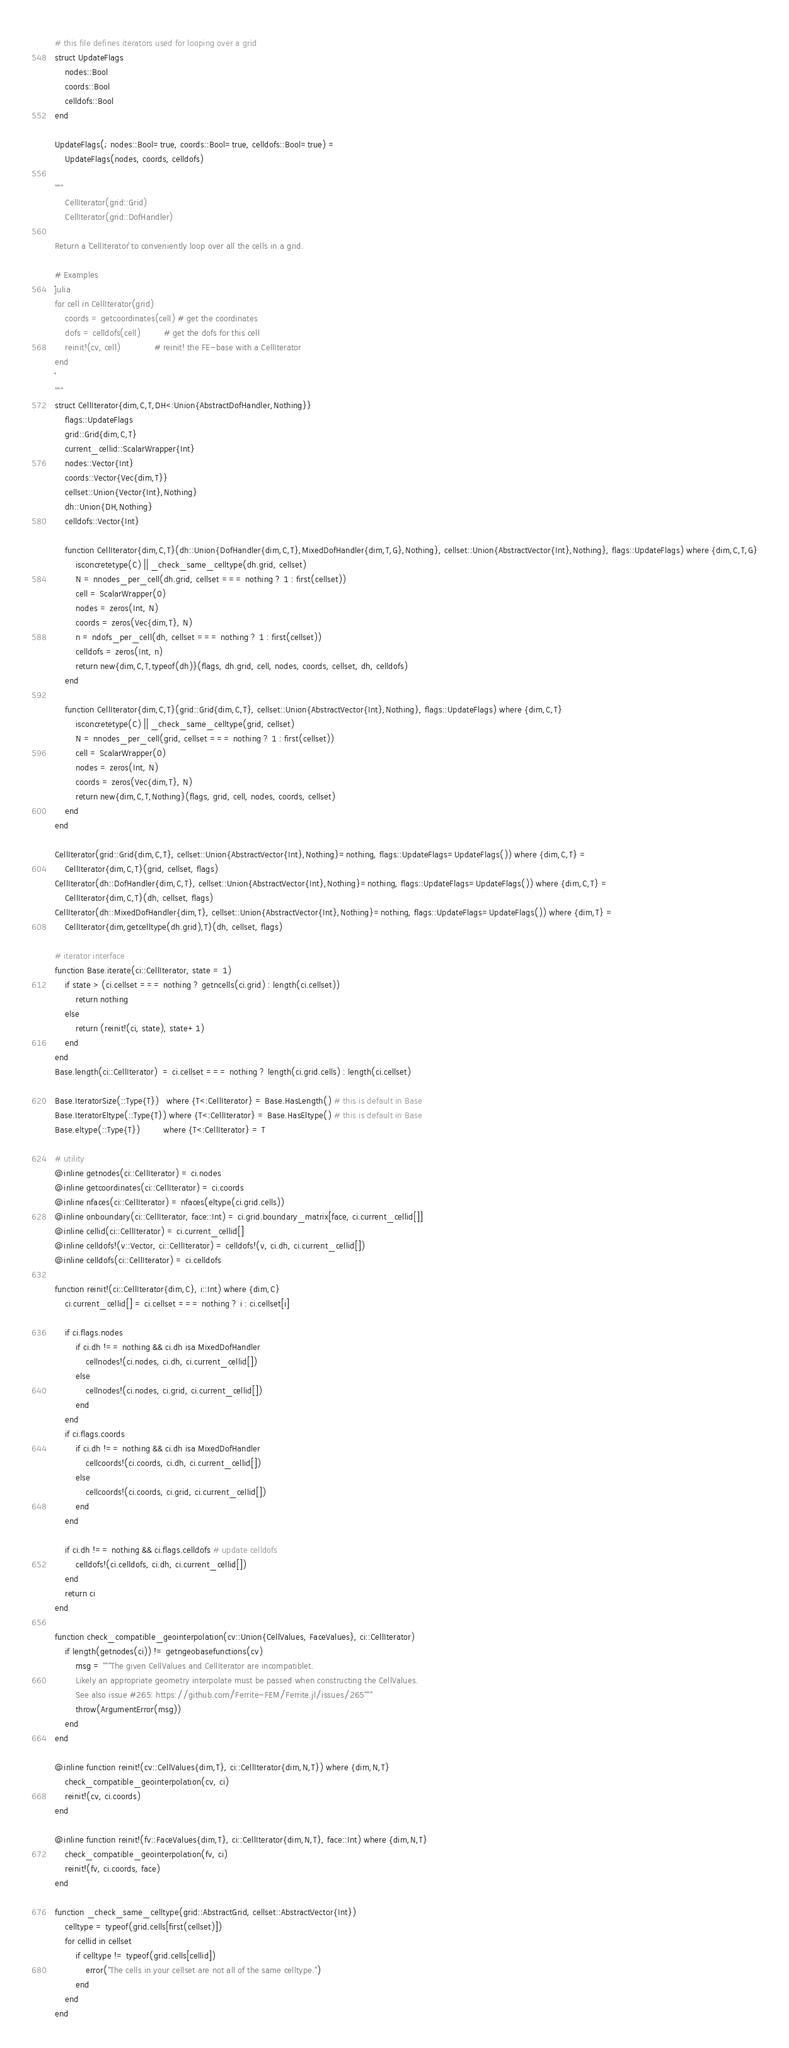<code> <loc_0><loc_0><loc_500><loc_500><_Julia_># this file defines iterators used for looping over a grid
struct UpdateFlags
    nodes::Bool
    coords::Bool
    celldofs::Bool
end

UpdateFlags(; nodes::Bool=true, coords::Bool=true, celldofs::Bool=true) =
    UpdateFlags(nodes, coords, celldofs)

"""
    CellIterator(grid::Grid)
    CellIterator(grid::DofHandler)

Return a `CellIterator` to conveniently loop over all the cells in a grid.

# Examples
```julia
for cell in CellIterator(grid)
    coords = getcoordinates(cell) # get the coordinates
    dofs = celldofs(cell)         # get the dofs for this cell
    reinit!(cv, cell)             # reinit! the FE-base with a CellIterator
end
```
"""
struct CellIterator{dim,C,T,DH<:Union{AbstractDofHandler,Nothing}}
    flags::UpdateFlags
    grid::Grid{dim,C,T}
    current_cellid::ScalarWrapper{Int}
    nodes::Vector{Int}
    coords::Vector{Vec{dim,T}}
    cellset::Union{Vector{Int},Nothing}
    dh::Union{DH,Nothing}
    celldofs::Vector{Int}

    function CellIterator{dim,C,T}(dh::Union{DofHandler{dim,C,T},MixedDofHandler{dim,T,G},Nothing}, cellset::Union{AbstractVector{Int},Nothing}, flags::UpdateFlags) where {dim,C,T,G}
        isconcretetype(C) || _check_same_celltype(dh.grid, cellset)
        N = nnodes_per_cell(dh.grid, cellset === nothing ? 1 : first(cellset))
        cell = ScalarWrapper(0)
        nodes = zeros(Int, N)
        coords = zeros(Vec{dim,T}, N)
        n = ndofs_per_cell(dh, cellset === nothing ? 1 : first(cellset))
        celldofs = zeros(Int, n)
        return new{dim,C,T,typeof(dh)}(flags, dh.grid, cell, nodes, coords, cellset, dh, celldofs)
    end

    function CellIterator{dim,C,T}(grid::Grid{dim,C,T}, cellset::Union{AbstractVector{Int},Nothing}, flags::UpdateFlags) where {dim,C,T}
        isconcretetype(C) || _check_same_celltype(grid, cellset)
        N = nnodes_per_cell(grid, cellset === nothing ? 1 : first(cellset))
        cell = ScalarWrapper(0)
        nodes = zeros(Int, N)
        coords = zeros(Vec{dim,T}, N)
        return new{dim,C,T,Nothing}(flags, grid, cell, nodes, coords, cellset)
    end
end

CellIterator(grid::Grid{dim,C,T}, cellset::Union{AbstractVector{Int},Nothing}=nothing, flags::UpdateFlags=UpdateFlags()) where {dim,C,T} =
    CellIterator{dim,C,T}(grid, cellset, flags)
CellIterator(dh::DofHandler{dim,C,T}, cellset::Union{AbstractVector{Int},Nothing}=nothing, flags::UpdateFlags=UpdateFlags()) where {dim,C,T} =
    CellIterator{dim,C,T}(dh, cellset, flags)
CellIterator(dh::MixedDofHandler{dim,T}, cellset::Union{AbstractVector{Int},Nothing}=nothing, flags::UpdateFlags=UpdateFlags()) where {dim,T} =
    CellIterator{dim,getcelltype(dh.grid),T}(dh, cellset, flags)

# iterator interface
function Base.iterate(ci::CellIterator, state = 1)
    if state > (ci.cellset === nothing ? getncells(ci.grid) : length(ci.cellset))
        return nothing
    else
        return (reinit!(ci, state), state+1)
    end
end
Base.length(ci::CellIterator)  = ci.cellset === nothing ? length(ci.grid.cells) : length(ci.cellset)

Base.IteratorSize(::Type{T})   where {T<:CellIterator} = Base.HasLength() # this is default in Base
Base.IteratorEltype(::Type{T}) where {T<:CellIterator} = Base.HasEltype() # this is default in Base
Base.eltype(::Type{T})         where {T<:CellIterator} = T

# utility
@inline getnodes(ci::CellIterator) = ci.nodes
@inline getcoordinates(ci::CellIterator) = ci.coords
@inline nfaces(ci::CellIterator) = nfaces(eltype(ci.grid.cells))
@inline onboundary(ci::CellIterator, face::Int) = ci.grid.boundary_matrix[face, ci.current_cellid[]]
@inline cellid(ci::CellIterator) = ci.current_cellid[]
@inline celldofs!(v::Vector, ci::CellIterator) = celldofs!(v, ci.dh, ci.current_cellid[])
@inline celldofs(ci::CellIterator) = ci.celldofs

function reinit!(ci::CellIterator{dim,C}, i::Int) where {dim,C}
    ci.current_cellid[] = ci.cellset === nothing ? i : ci.cellset[i]

    if ci.flags.nodes
        if ci.dh !== nothing && ci.dh isa MixedDofHandler
            cellnodes!(ci.nodes, ci.dh, ci.current_cellid[])
        else
            cellnodes!(ci.nodes, ci.grid, ci.current_cellid[])
        end
    end
    if ci.flags.coords
        if ci.dh !== nothing && ci.dh isa MixedDofHandler
            cellcoords!(ci.coords, ci.dh, ci.current_cellid[])
        else
            cellcoords!(ci.coords, ci.grid, ci.current_cellid[])
        end
    end

    if ci.dh !== nothing && ci.flags.celldofs # update celldofs
        celldofs!(ci.celldofs, ci.dh, ci.current_cellid[])
    end
    return ci
end

function check_compatible_geointerpolation(cv::Union{CellValues, FaceValues}, ci::CellIterator)
    if length(getnodes(ci)) != getngeobasefunctions(cv)
        msg = """The given CellValues and CellIterator are incompatiblet.
        Likely an appropriate geometry interpolate must be passed when constructing the CellValues.
        See also issue #265: https://github.com/Ferrite-FEM/Ferrite.jl/issues/265"""
        throw(ArgumentError(msg))
    end
end

@inline function reinit!(cv::CellValues{dim,T}, ci::CellIterator{dim,N,T}) where {dim,N,T}
    check_compatible_geointerpolation(cv, ci)
    reinit!(cv, ci.coords)
end

@inline function reinit!(fv::FaceValues{dim,T}, ci::CellIterator{dim,N,T}, face::Int) where {dim,N,T}
    check_compatible_geointerpolation(fv, ci)
    reinit!(fv, ci.coords, face)
end

function _check_same_celltype(grid::AbstractGrid, cellset::AbstractVector{Int})
    celltype = typeof(grid.cells[first(cellset)])
    for cellid in cellset
        if celltype != typeof(grid.cells[cellid])
            error("The cells in your cellset are not all of the same celltype.")
        end
    end
end
</code> 